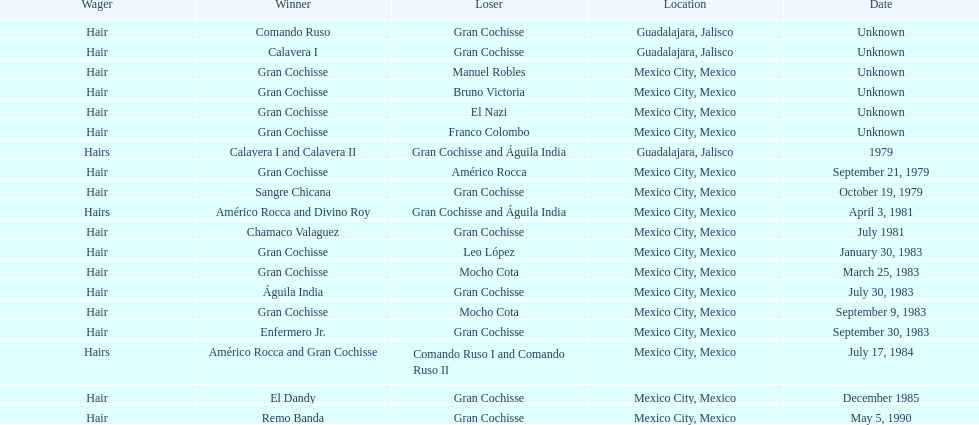Before bruno victoria was defeated, how many people had won? 3. 